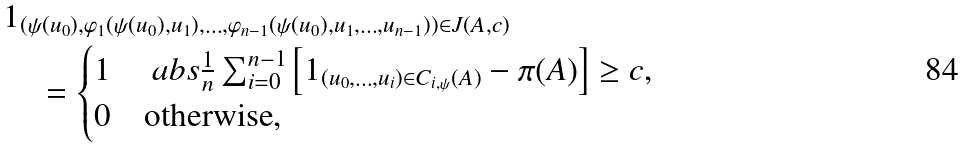<formula> <loc_0><loc_0><loc_500><loc_500>& 1 _ { ( \psi ( u _ { 0 } ) , \varphi _ { 1 } ( \psi ( u _ { 0 } ) , u _ { 1 } ) , \dots , \varphi _ { n - 1 } ( \psi ( u _ { 0 } ) , u _ { 1 } , \dots , u _ { n - 1 } ) ) \in J ( A , c ) } \\ & \quad = \begin{cases} 1 & \ a b s { \frac { 1 } { n } \sum _ { i = 0 } ^ { n - 1 } \left [ 1 _ { ( u _ { 0 } , \dots , u _ { i } ) \in C _ { i , \psi } ( A ) } - \pi ( A ) \right ] } \geq c , \\ 0 & \text {otherwise} , \end{cases}</formula> 